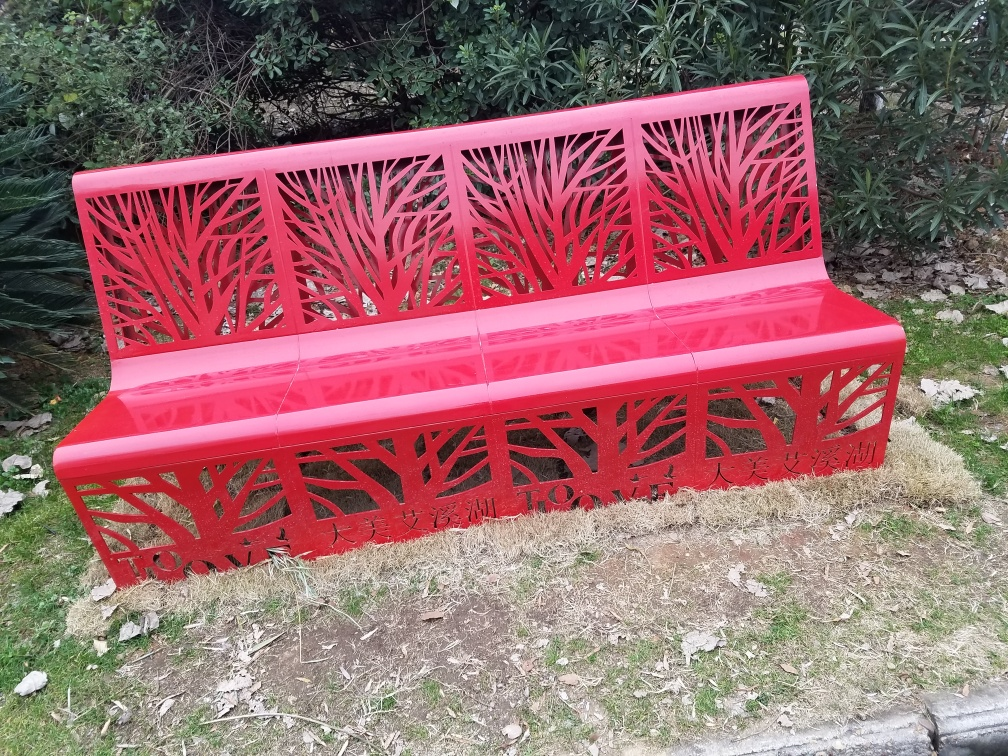What is the style of the bench design? The bench has a contemporary style with a nature-inspired design featuring silhouettes of trees and branches. It offers a modern take on outdoor furniture with a touch of artistic flair. 